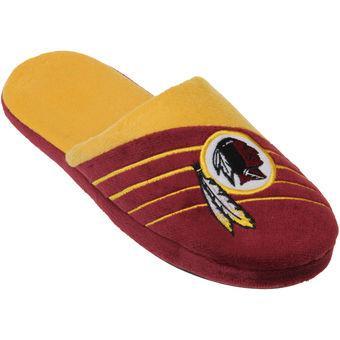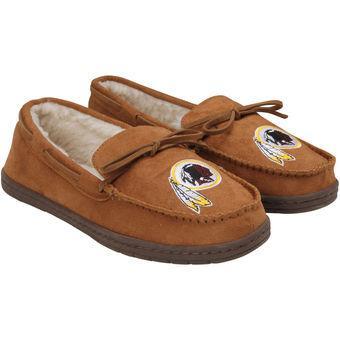The first image is the image on the left, the second image is the image on the right. Given the left and right images, does the statement "Each footwear item features a sillhouette of an Indian warrior, and the left image contains one yellow and burgundy slipper, while the right image contains a pair of moccasins." hold true? Answer yes or no. Yes. The first image is the image on the left, the second image is the image on the right. For the images shown, is this caption "A tan pair of moccasins in one image has a sports logo on each one that is the same logo seen on a red and yellow slipper in the other image." true? Answer yes or no. Yes. 